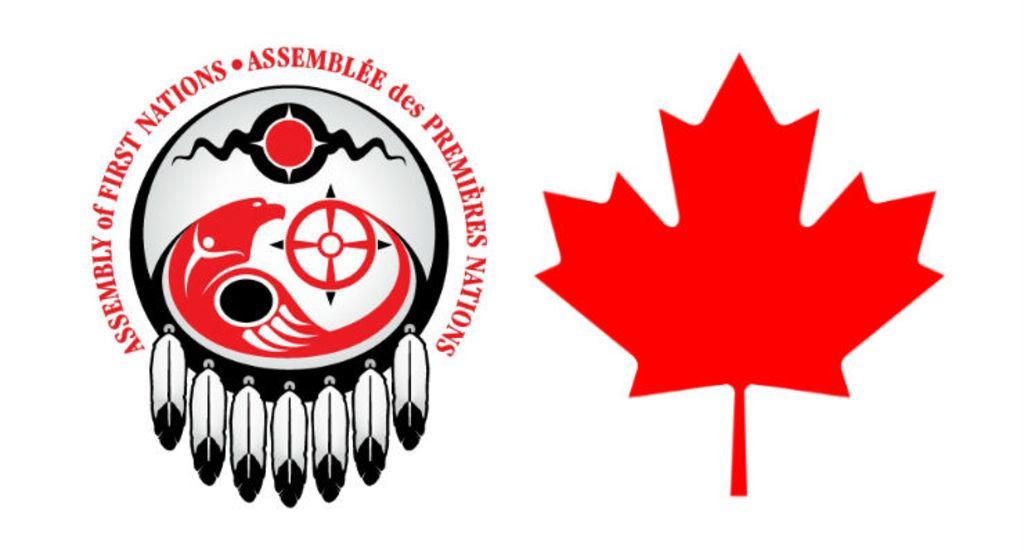How would you summarize this image in a sentence or two? On the left side of the picture, we see the logo of the Assembly of First Nations. On the right side, we see an illustration of a leaf and a flower. It is in red color. In the background, it is white in color. 